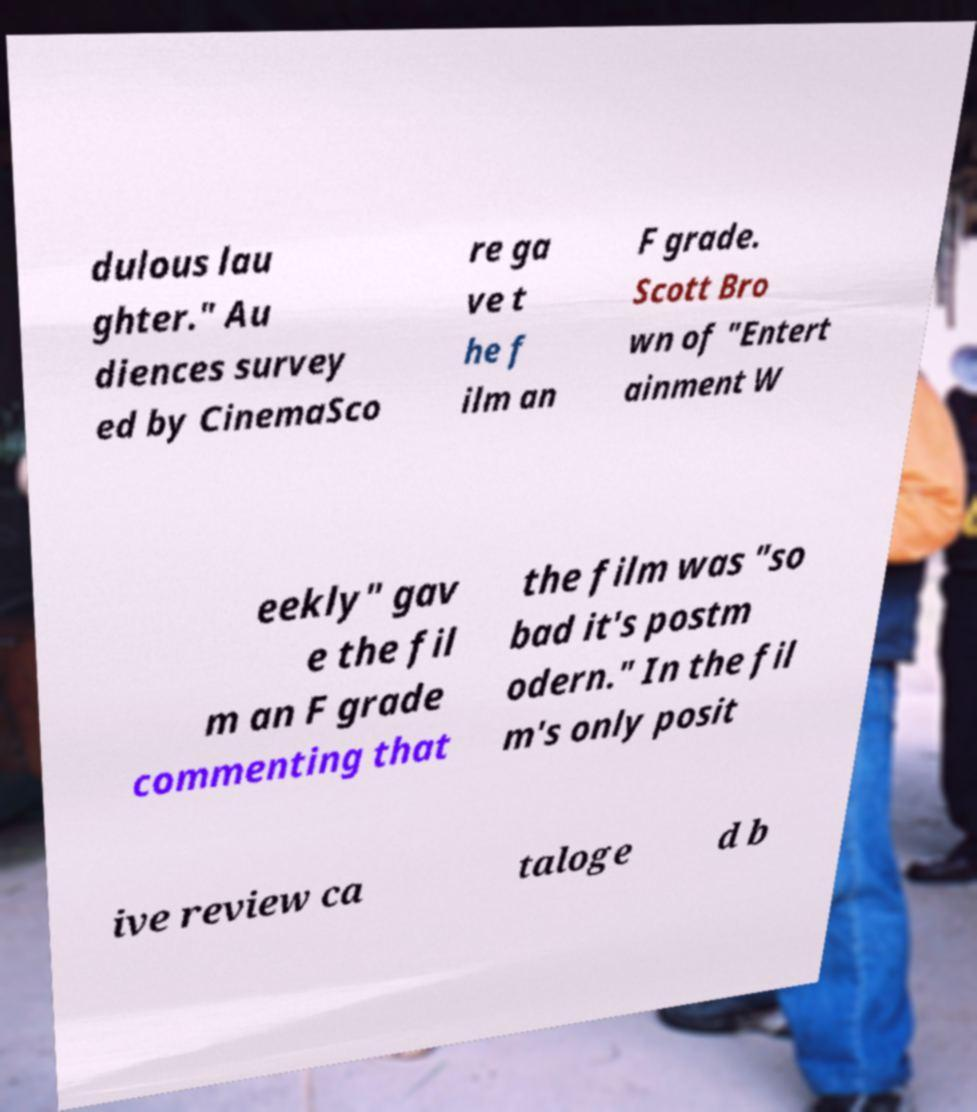Can you read and provide the text displayed in the image?This photo seems to have some interesting text. Can you extract and type it out for me? dulous lau ghter." Au diences survey ed by CinemaSco re ga ve t he f ilm an F grade. Scott Bro wn of "Entert ainment W eekly" gav e the fil m an F grade commenting that the film was "so bad it's postm odern." In the fil m's only posit ive review ca taloge d b 